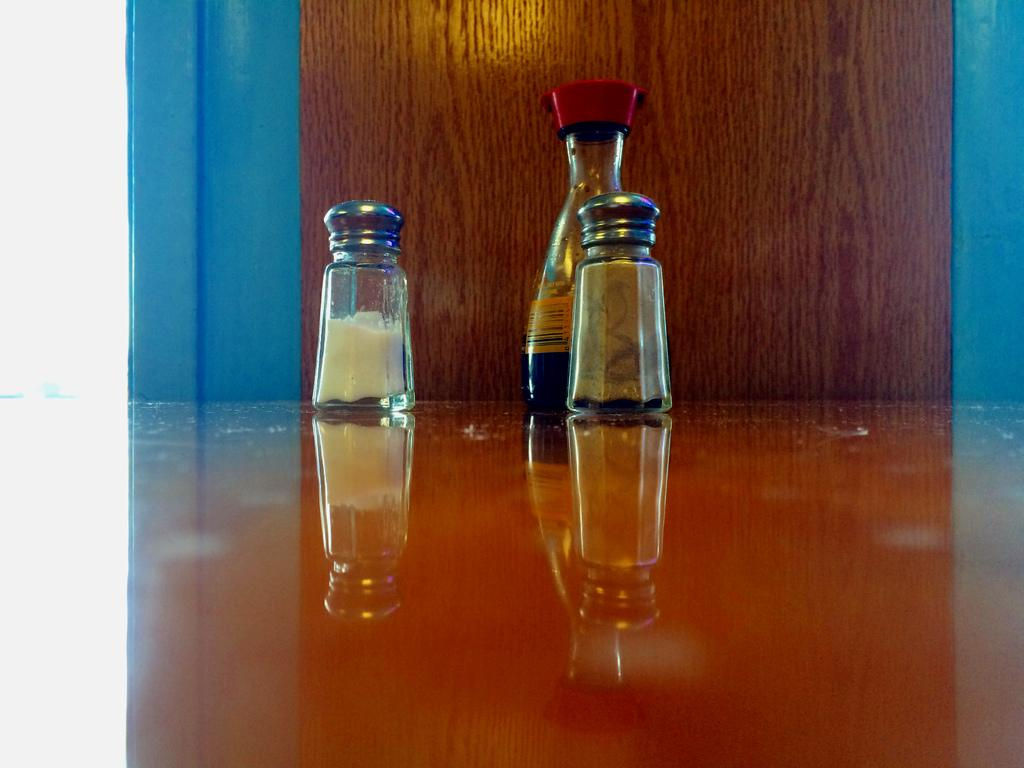How many small bottles are visible in the image? There are three small bottles in the image. What type of stitch is used to sew the wings on the small bottles in the image? There are no wings or stitches present on the small bottles in the image. 